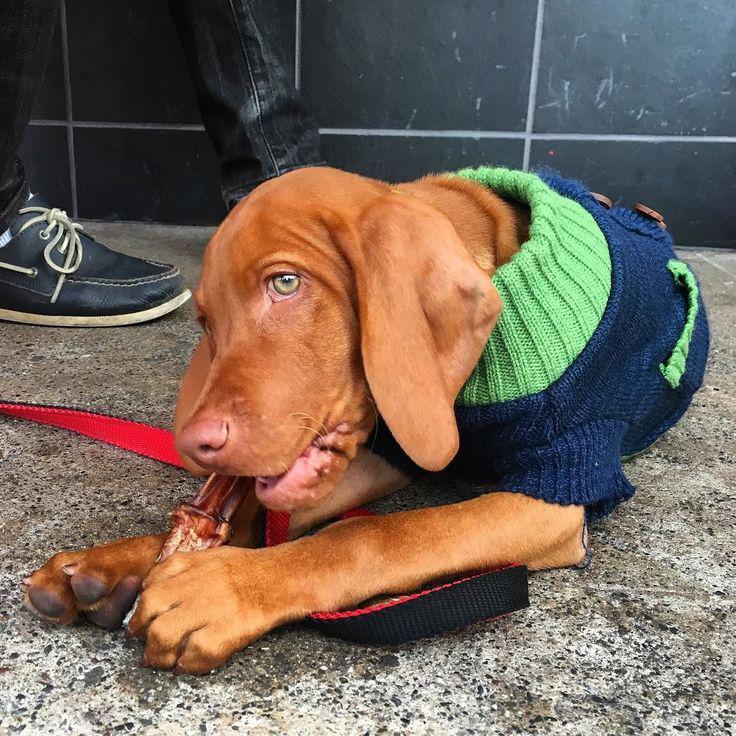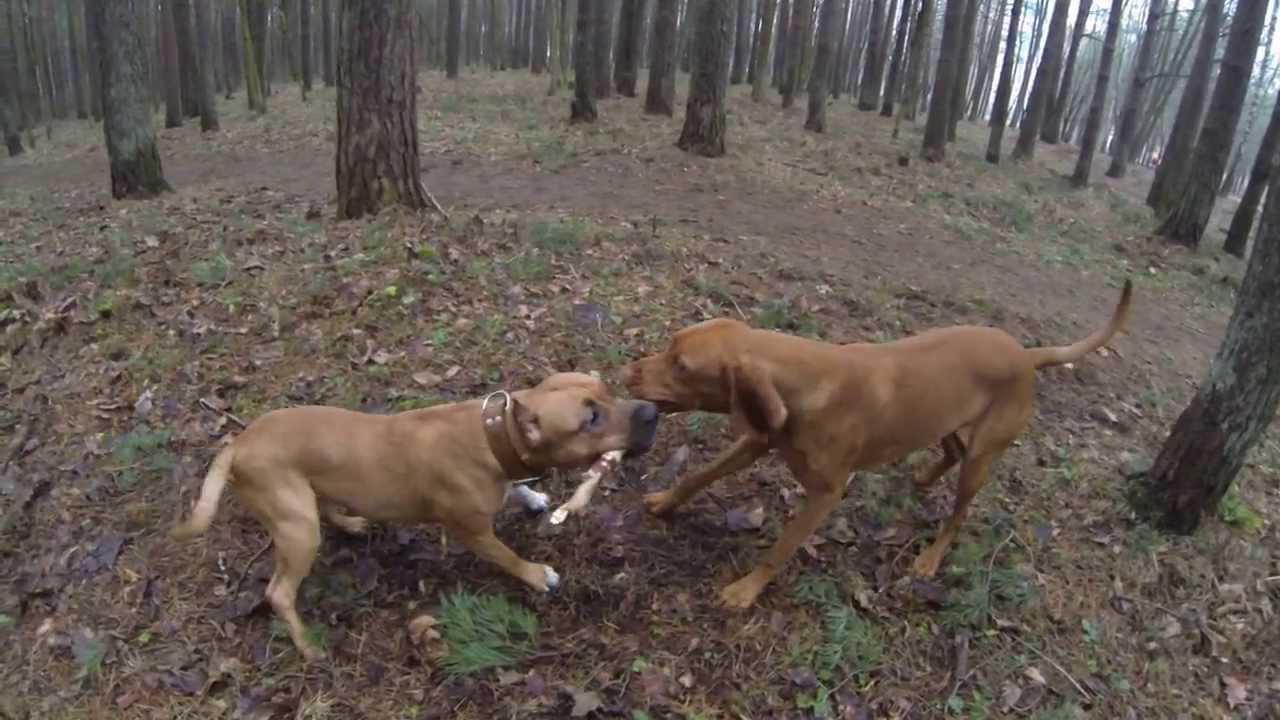The first image is the image on the left, the second image is the image on the right. Analyze the images presented: Is the assertion "In total, two dogs are outdoors with a wooden stick grasped in their mouth." valid? Answer yes or no. Yes. The first image is the image on the left, the second image is the image on the right. Considering the images on both sides, is "One dog is laying down." valid? Answer yes or no. Yes. 